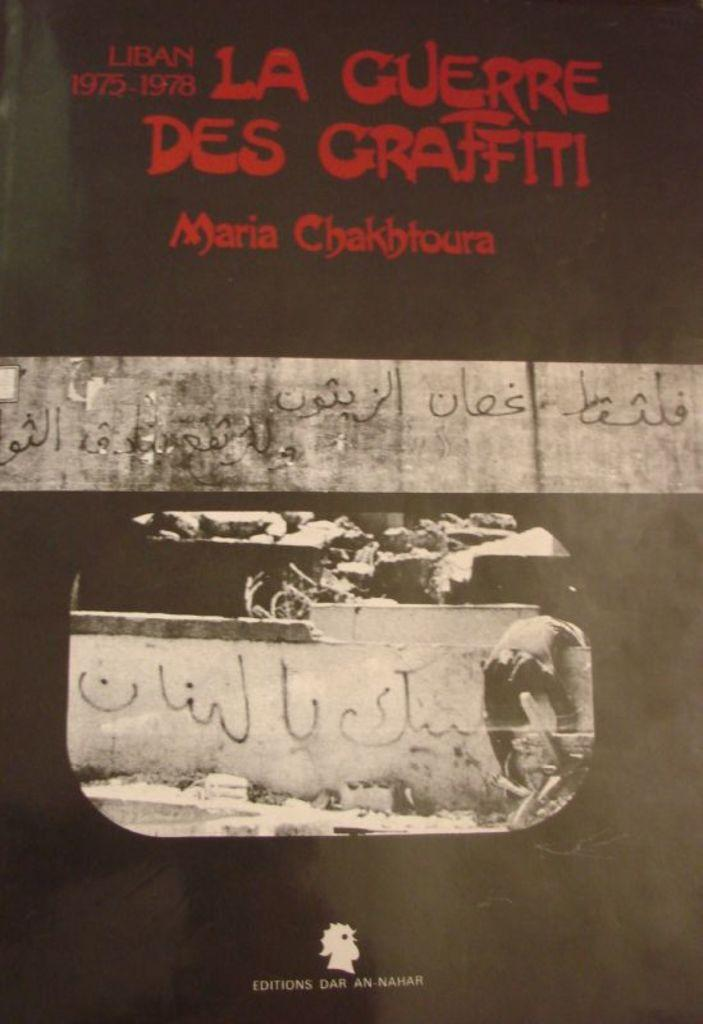<image>
Give a short and clear explanation of the subsequent image. A poster which reads La Guerre Des Graffiti written in red letters. 